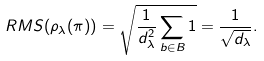Convert formula to latex. <formula><loc_0><loc_0><loc_500><loc_500>R M S ( \rho _ { \lambda } ( \pi ) ) = \sqrt { \frac { 1 } { d _ { \lambda } ^ { 2 } } \sum _ { b \in B } 1 } = \frac { 1 } { \sqrt { d _ { \lambda } } } .</formula> 